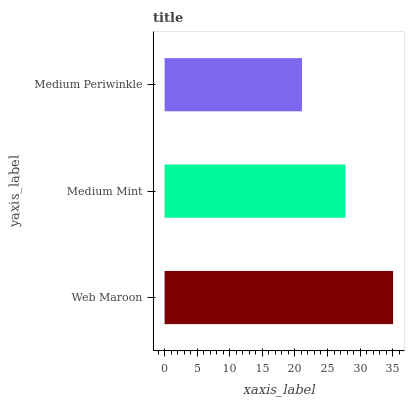Is Medium Periwinkle the minimum?
Answer yes or no. Yes. Is Web Maroon the maximum?
Answer yes or no. Yes. Is Medium Mint the minimum?
Answer yes or no. No. Is Medium Mint the maximum?
Answer yes or no. No. Is Web Maroon greater than Medium Mint?
Answer yes or no. Yes. Is Medium Mint less than Web Maroon?
Answer yes or no. Yes. Is Medium Mint greater than Web Maroon?
Answer yes or no. No. Is Web Maroon less than Medium Mint?
Answer yes or no. No. Is Medium Mint the high median?
Answer yes or no. Yes. Is Medium Mint the low median?
Answer yes or no. Yes. Is Web Maroon the high median?
Answer yes or no. No. Is Medium Periwinkle the low median?
Answer yes or no. No. 